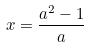Convert formula to latex. <formula><loc_0><loc_0><loc_500><loc_500>x = \frac { a ^ { 2 } - 1 } { a }</formula> 